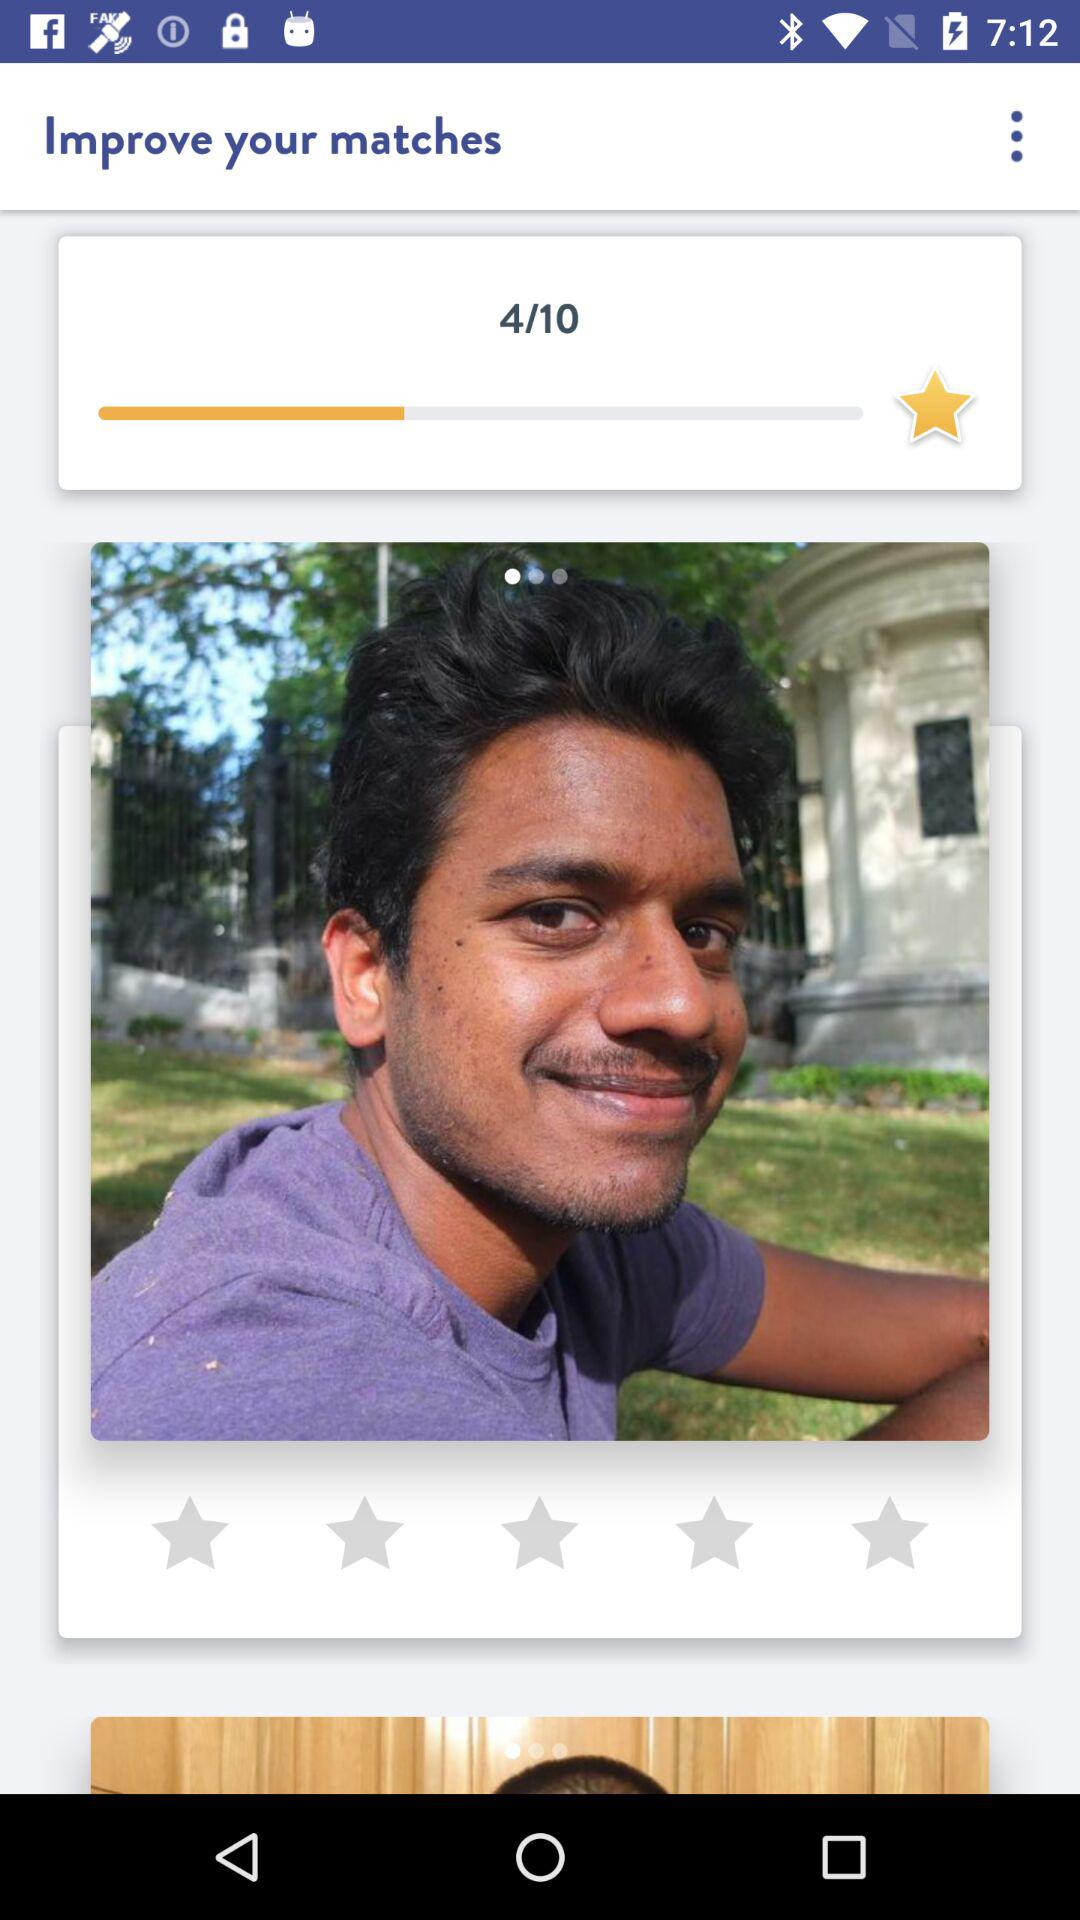How many stars were achieved out of 10? There are 4 stars achieved out of 10. 